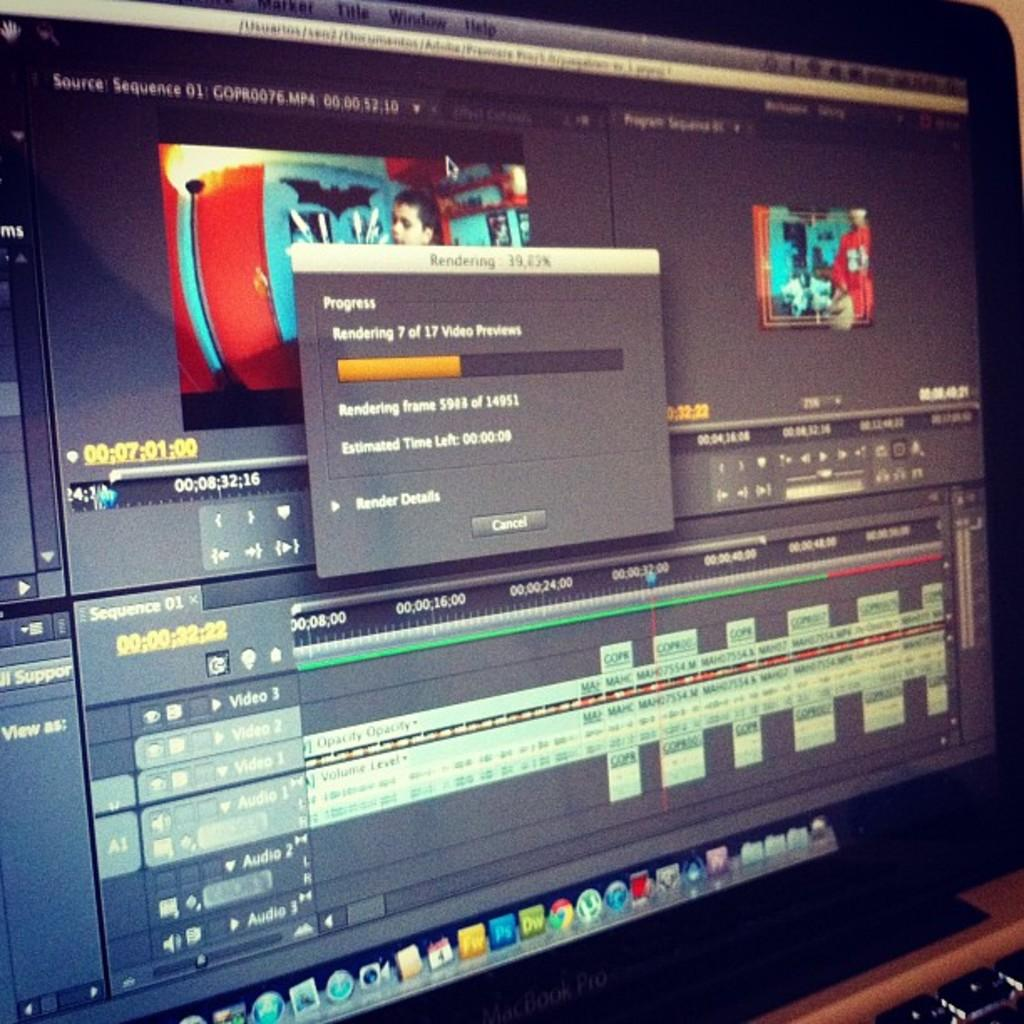Provide a one-sentence caption for the provided image. The computer is in the process of rendering number 7 out of 17 videos. 